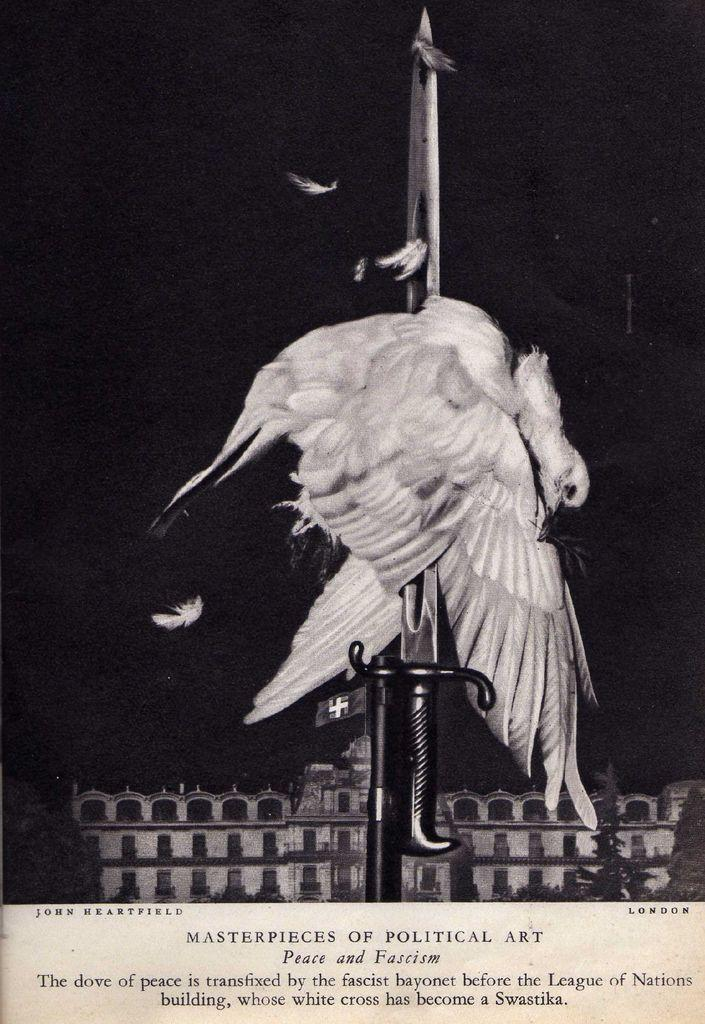Provide a one-sentence caption for the provided image. a picture of one of the masterpieces of political art called 'peace and fassicm'. 